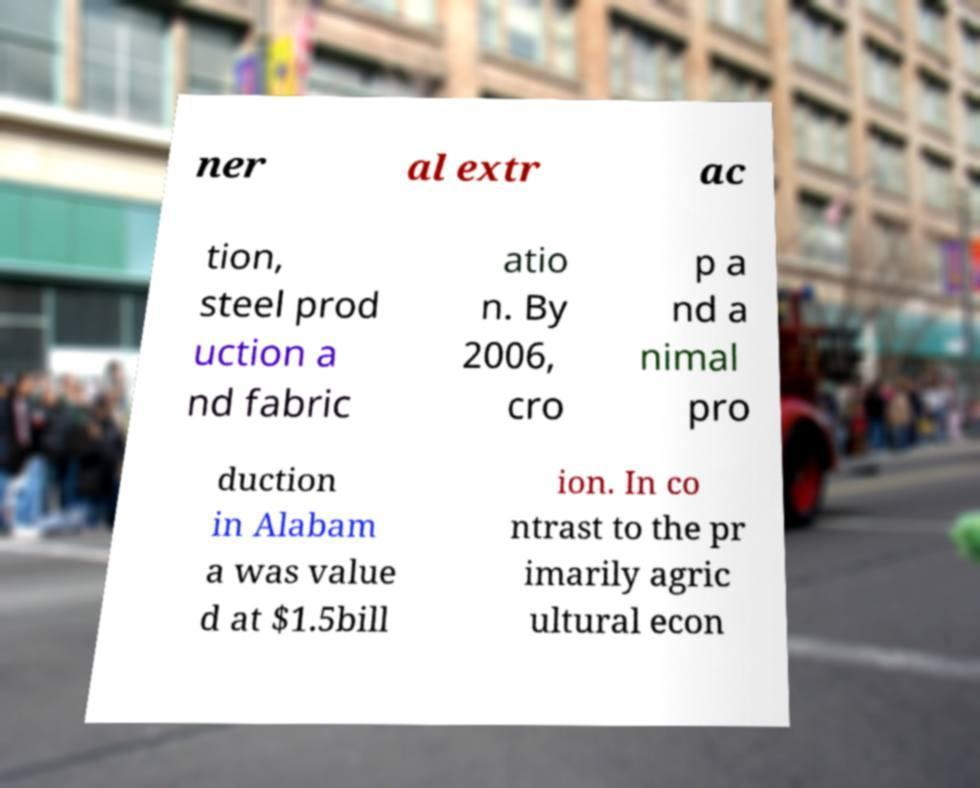Could you extract and type out the text from this image? ner al extr ac tion, steel prod uction a nd fabric atio n. By 2006, cro p a nd a nimal pro duction in Alabam a was value d at $1.5bill ion. In co ntrast to the pr imarily agric ultural econ 